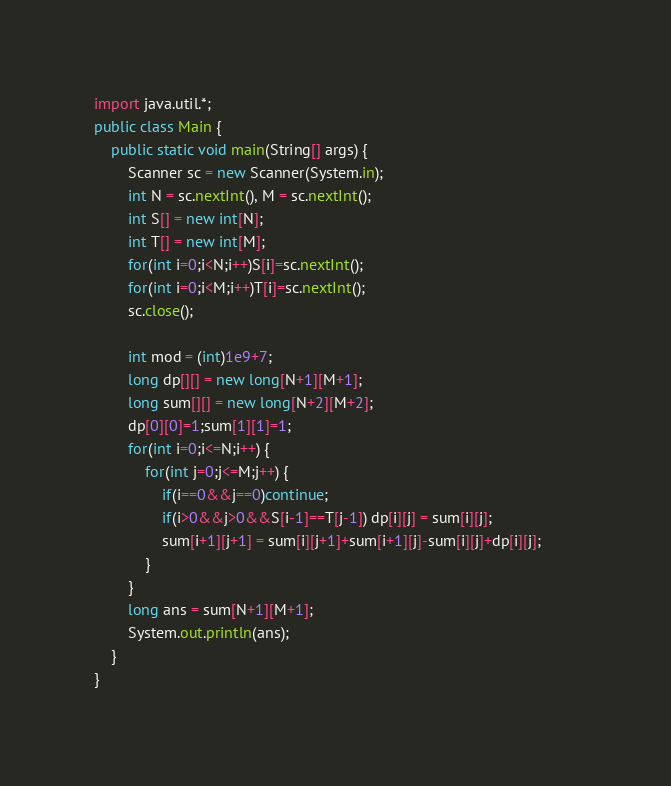<code> <loc_0><loc_0><loc_500><loc_500><_Java_>import java.util.*;
public class Main {
	public static void main(String[] args) {
		Scanner sc = new Scanner(System.in);
		int N = sc.nextInt(), M = sc.nextInt();
		int S[] = new int[N];
		int T[] = new int[M];
		for(int i=0;i<N;i++)S[i]=sc.nextInt();
		for(int i=0;i<M;i++)T[i]=sc.nextInt();
		sc.close();
		
		int mod = (int)1e9+7;
		long dp[][] = new long[N+1][M+1];
		long sum[][] = new long[N+2][M+2];
		dp[0][0]=1;sum[1][1]=1;
		for(int i=0;i<=N;i++) {
			for(int j=0;j<=M;j++) {
				if(i==0&&j==0)continue;
				if(i>0&&j>0&&S[i-1]==T[j-1]) dp[i][j] = sum[i][j];					
				sum[i+1][j+1] = sum[i][j+1]+sum[i+1][j]-sum[i][j]+dp[i][j];
			}
		}
		long ans = sum[N+1][M+1];
		System.out.println(ans);
	}
}
</code> 